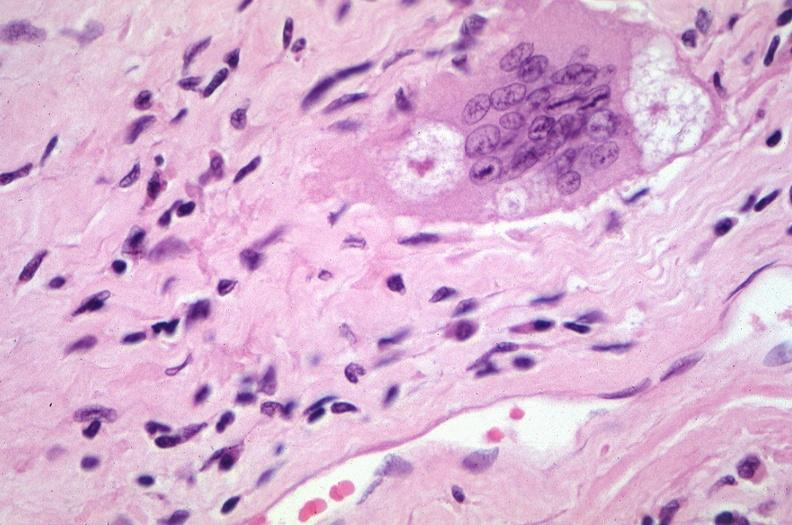what is present?
Answer the question using a single word or phrase. Respiratory 